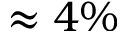<formula> <loc_0><loc_0><loc_500><loc_500>\approx 4 \%</formula> 